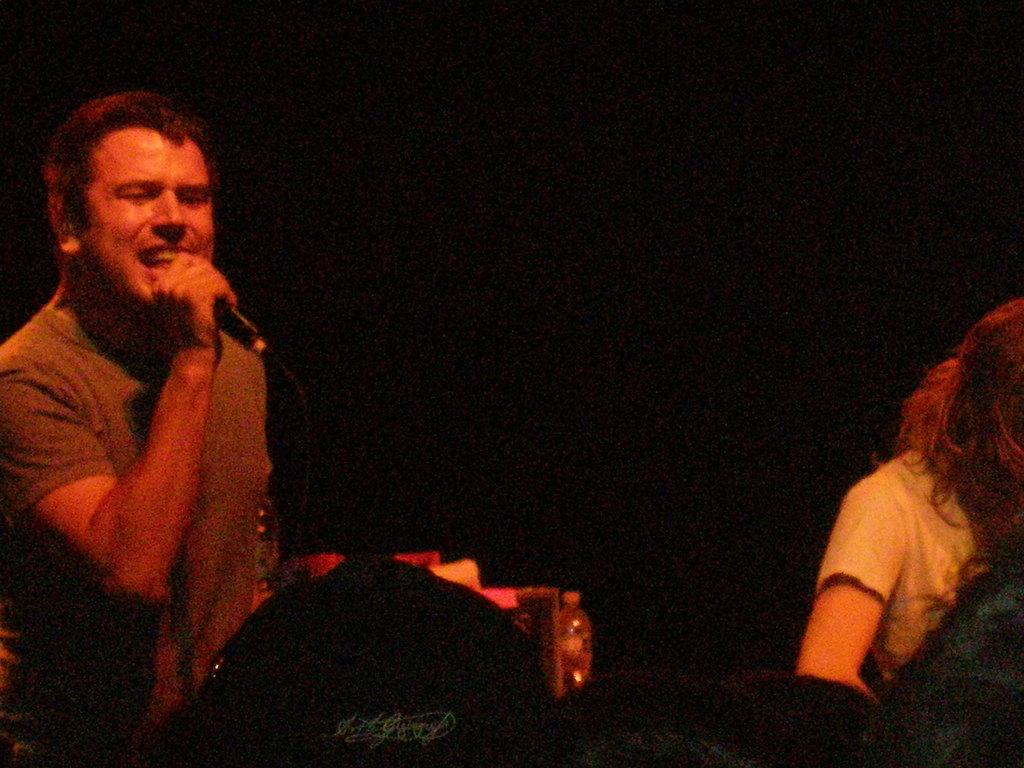How many people are in the image? There are two persons in the image. What is one of the persons holding? One of the persons is holding a mic. Can you describe the lighting in the image? The image is slightly dark. What type of coat is the girl wearing in the image? There is no girl present in the image, and no one is wearing a coat. 